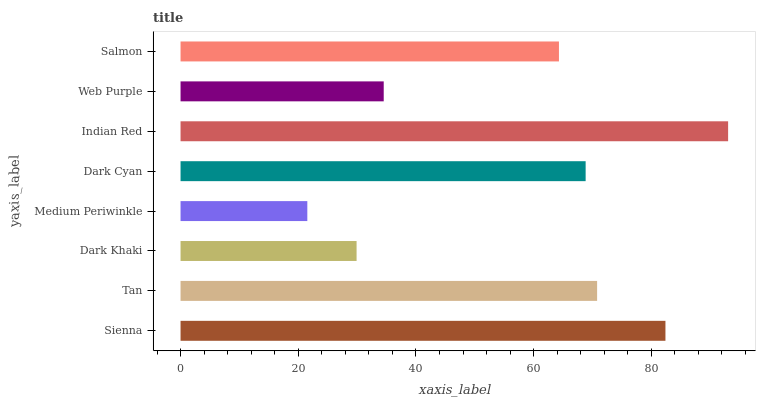Is Medium Periwinkle the minimum?
Answer yes or no. Yes. Is Indian Red the maximum?
Answer yes or no. Yes. Is Tan the minimum?
Answer yes or no. No. Is Tan the maximum?
Answer yes or no. No. Is Sienna greater than Tan?
Answer yes or no. Yes. Is Tan less than Sienna?
Answer yes or no. Yes. Is Tan greater than Sienna?
Answer yes or no. No. Is Sienna less than Tan?
Answer yes or no. No. Is Dark Cyan the high median?
Answer yes or no. Yes. Is Salmon the low median?
Answer yes or no. Yes. Is Web Purple the high median?
Answer yes or no. No. Is Sienna the low median?
Answer yes or no. No. 